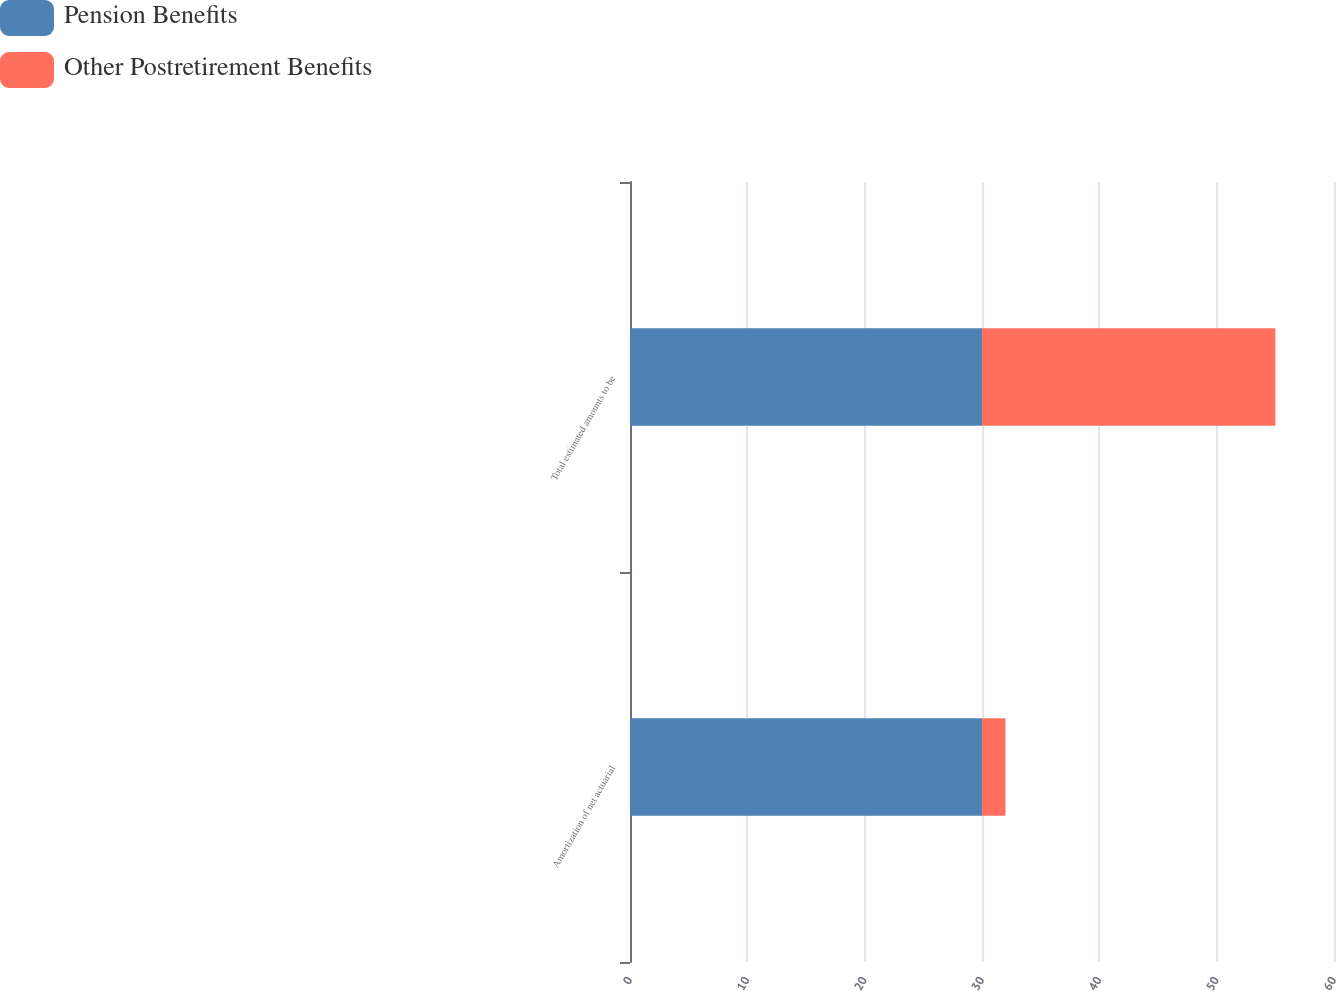<chart> <loc_0><loc_0><loc_500><loc_500><stacked_bar_chart><ecel><fcel>Amortization of net actuarial<fcel>Total estimated amounts to be<nl><fcel>Pension Benefits<fcel>30<fcel>30<nl><fcel>Other Postretirement Benefits<fcel>2<fcel>25<nl></chart> 